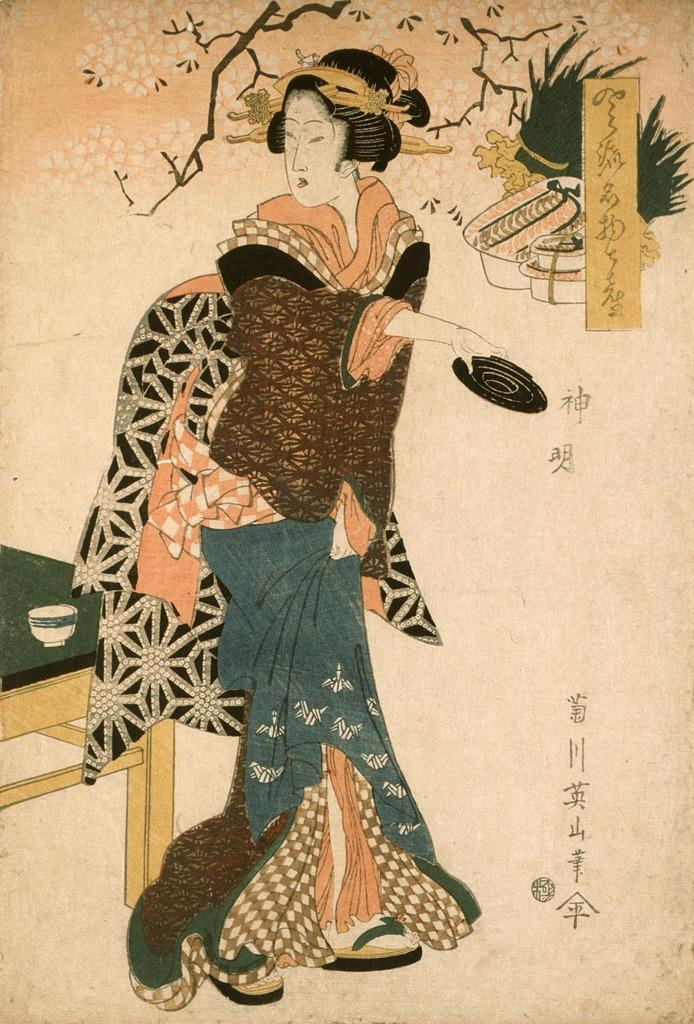Could you give a brief overview of what you see in this image? In this image I can see the depiction picture of a woman. I can see she is holding a black colour thing. I can also see other depiction things like a plant, a table, a cup and few other stuffs. On the right side of the image I can see something is written. 